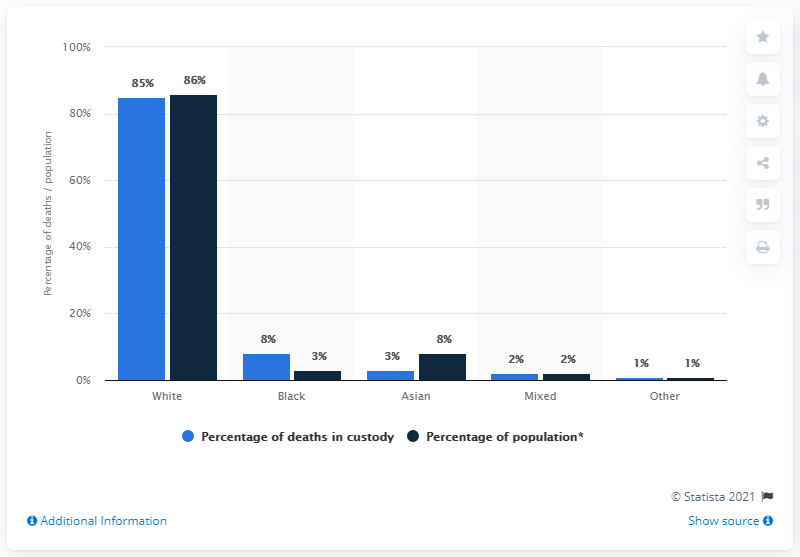Specify some key components in this picture. According to the information provided, the race groups of Mixed and Other have percentages of deaths in police custody that are the same as their percentages in the overall English and Welsh population. 